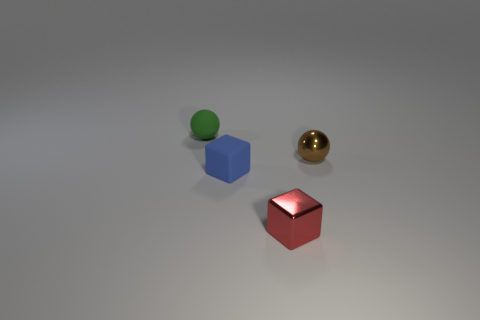Is the green sphere made of the same material as the tiny red object that is on the left side of the brown object?
Ensure brevity in your answer.  No. The sphere that is on the right side of the small metallic thing in front of the small metallic thing behind the red metal block is what color?
Your response must be concise. Brown. Are there more blue rubber objects than cyan cylinders?
Make the answer very short. Yes. What number of small spheres are behind the brown metallic object and in front of the tiny green ball?
Keep it short and to the point. 0. There is a sphere that is behind the metal sphere; how many shiny spheres are to the left of it?
Make the answer very short. 0. Does the red shiny cube that is in front of the rubber block have the same size as the ball in front of the green rubber sphere?
Provide a short and direct response. Yes. What number of small rubber spheres are there?
Keep it short and to the point. 1. How many small red cubes are made of the same material as the small blue block?
Offer a terse response. 0. Are there an equal number of tiny blue matte things on the left side of the tiny green rubber thing and large yellow rubber cylinders?
Provide a short and direct response. Yes. There is a brown metallic sphere; is its size the same as the green rubber object left of the red block?
Provide a short and direct response. Yes. 